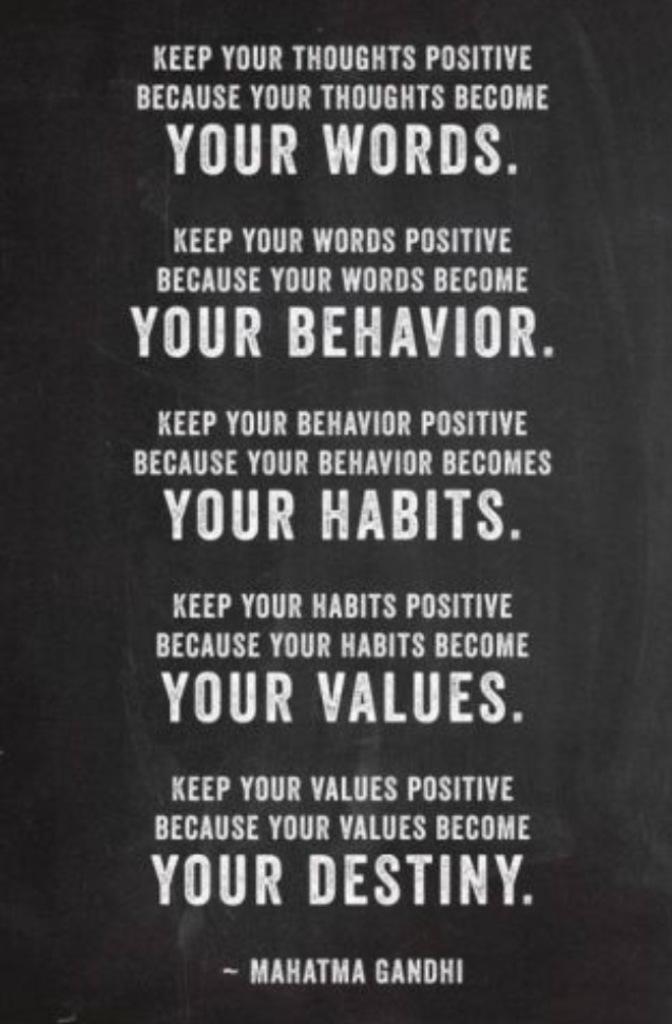Who is this quote by?
Make the answer very short. Mahatma gandhi. What is the first quote?
Ensure brevity in your answer.  Keep your thoughts positive because your thoughts become your words. 